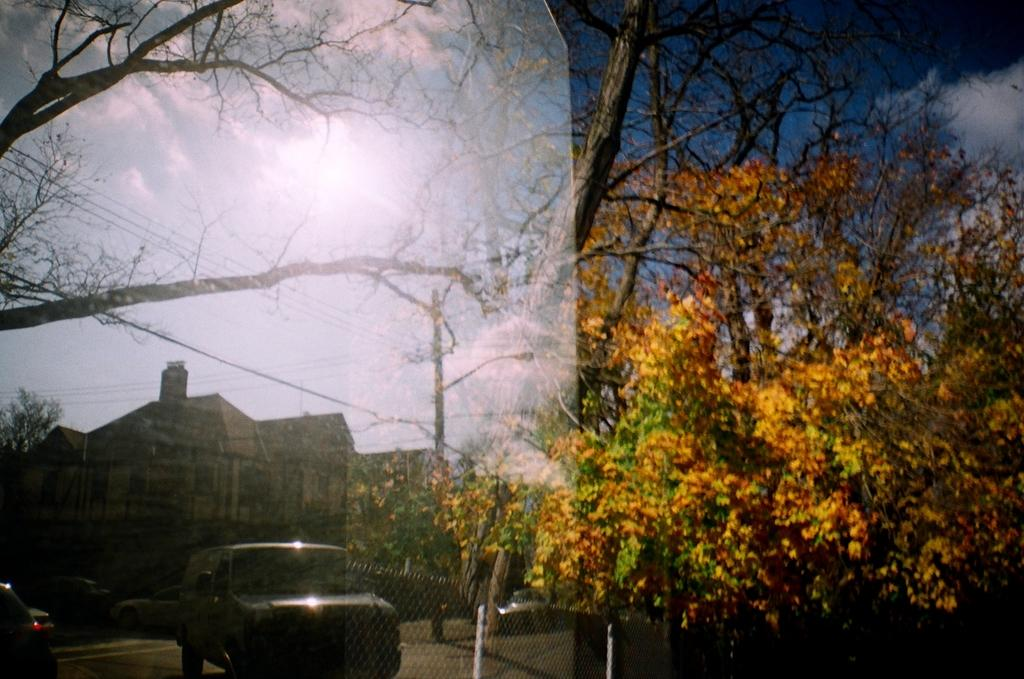What type of vegetation is on the right side of the image? There are trees on the right side of the image. What type of structures are on the left side of the image? There are houses on the left side of the image. Are there any trees on the left side of the image? Yes, there are trees on the left side of the image. What type of vehicles can be seen on the left side of the image? There are cars on the left side of the image. What is the weather like in the image? The weather is sunny. Can you see a ship sailing in the water in the image? There is no water or ship present in the image. How many kittens are playing on the trees in the image? There are no kittens present in the image. 